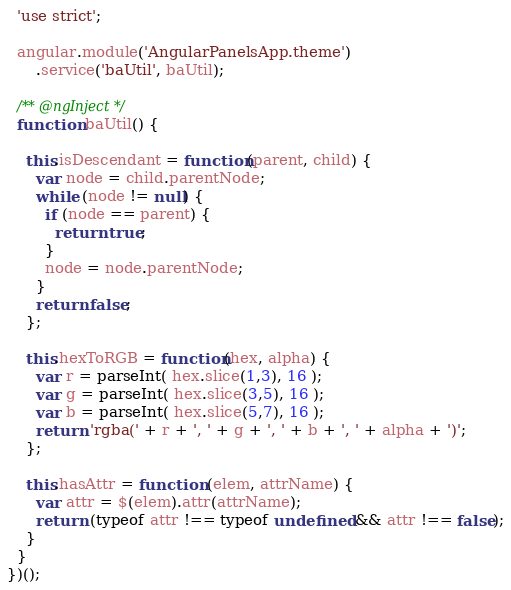Convert code to text. <code><loc_0><loc_0><loc_500><loc_500><_JavaScript_>  'use strict';

  angular.module('AngularPanelsApp.theme')
      .service('baUtil', baUtil);

  /** @ngInject */
  function baUtil() {

    this.isDescendant = function(parent, child) {
      var node = child.parentNode;
      while (node != null) {
        if (node == parent) {
          return true;
        }
        node = node.parentNode;
      }
      return false;
    };

    this.hexToRGB = function(hex, alpha) {
      var r = parseInt( hex.slice(1,3), 16 );
      var g = parseInt( hex.slice(3,5), 16 );
      var b = parseInt( hex.slice(5,7), 16 );
      return 'rgba(' + r + ', ' + g + ', ' + b + ', ' + alpha + ')';
    };

    this.hasAttr = function (elem, attrName) {
      var attr = $(elem).attr(attrName);
      return (typeof attr !== typeof undefined && attr !== false);
    }
  }
})();
</code> 